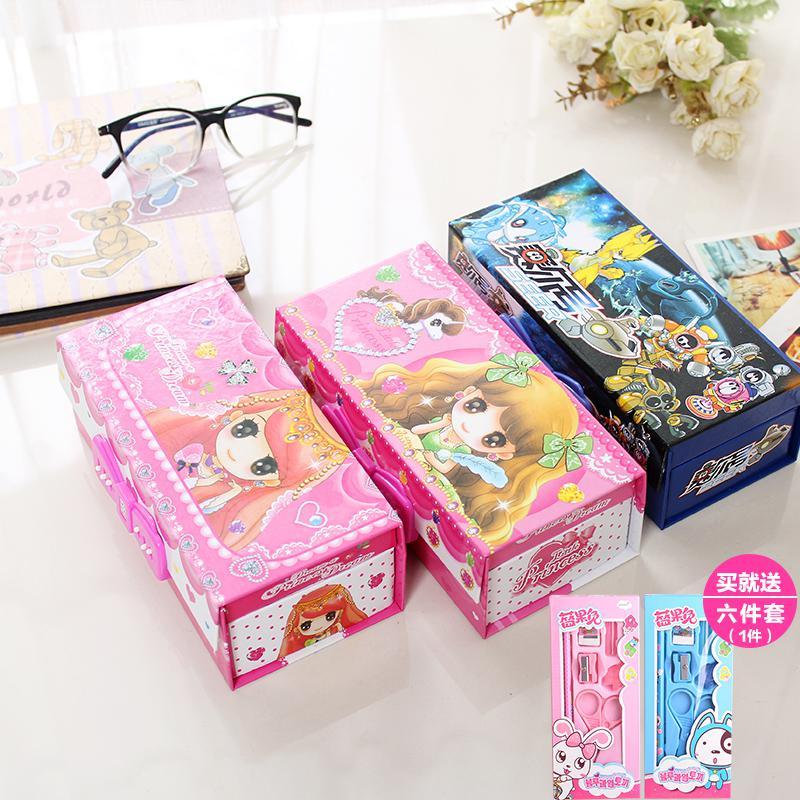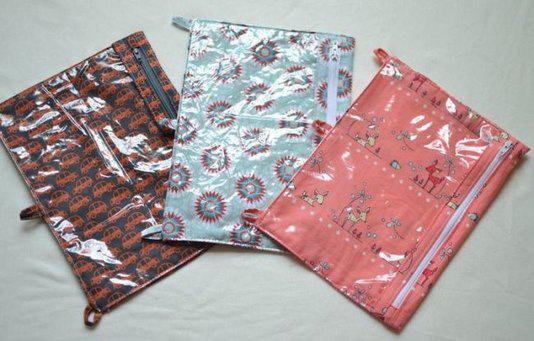The first image is the image on the left, the second image is the image on the right. Considering the images on both sides, is "A human hand is touchin a school supply." valid? Answer yes or no. No. The first image is the image on the left, the second image is the image on the right. Evaluate the accuracy of this statement regarding the images: "A hand is touching at least one rectangular patterned item in one image.". Is it true? Answer yes or no. No. 